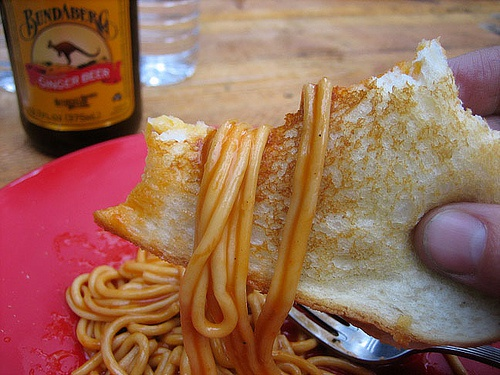Describe the objects in this image and their specific colors. I can see sandwich in black, olive, tan, darkgray, and gray tones, bottle in black, maroon, and brown tones, people in black, purple, maroon, and gray tones, cup in black, darkgray, lightblue, and lavender tones, and bottle in black, darkgray, lightblue, and lavender tones in this image. 